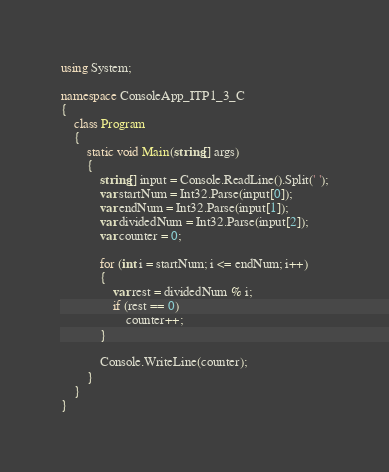<code> <loc_0><loc_0><loc_500><loc_500><_C#_>using System;

namespace ConsoleApp_ITP1_3_C
{
    class Program
    {
        static void Main(string[] args)
        {
            string[] input = Console.ReadLine().Split(' ');
            var startNum = Int32.Parse(input[0]);
            var endNum = Int32.Parse(input[1]);
            var dividedNum = Int32.Parse(input[2]);
            var counter = 0;

            for (int i = startNum; i <= endNum; i++)
            {
                var rest = dividedNum % i;
                if (rest == 0)
                    counter++;
            }

            Console.WriteLine(counter);
        }
    }
}

</code> 